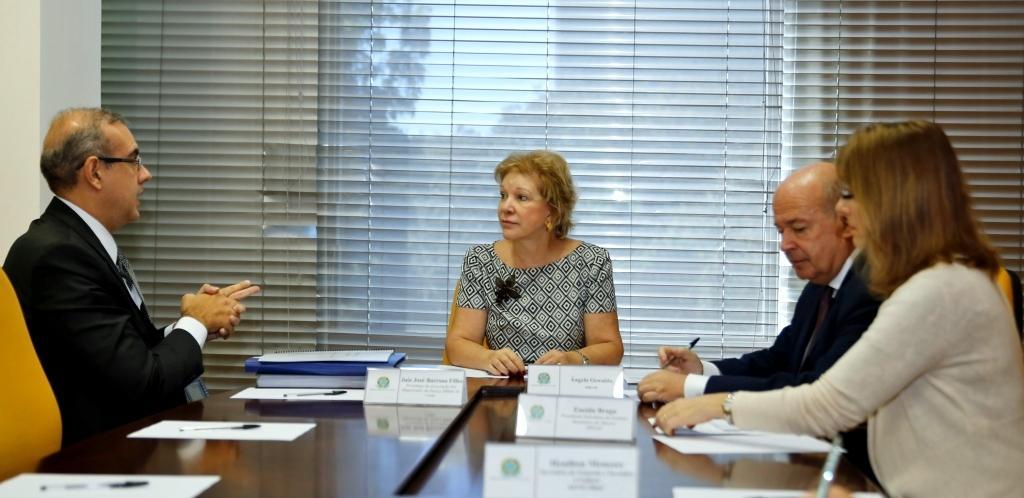Describe this image in one or two sentences. In this picture we can see four persons here man talking to the woman and her both carrying paper in their hand and here on table we can see name boards, files, papers, pen and in background we can see window with curtains. 